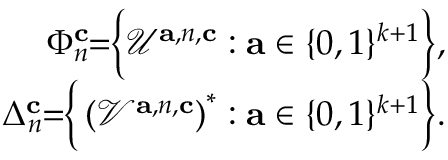Convert formula to latex. <formula><loc_0><loc_0><loc_500><loc_500>\begin{array} { r } { \Phi _ { n } ^ { c } \, = \, \left \{ \mathcal { U } ^ { a , { n } , c } \colon a \in \{ 0 , 1 \} ^ { k + 1 } \right \} , } \\ { \Delta _ { n } ^ { c } \, = \, \left \{ \left ( \mathcal { V } ^ { a , { n } , c } \right ) ^ { * } \colon a \in \{ 0 , 1 \} ^ { k + 1 } \right \} . } \end{array}</formula> 